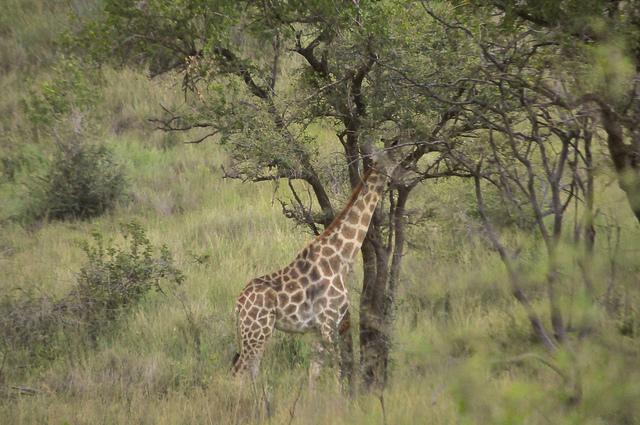How many giraffes are there?
Give a very brief answer. 1. How many animals are there?
Give a very brief answer. 1. How many giraffes are in the picture?
Give a very brief answer. 1. 